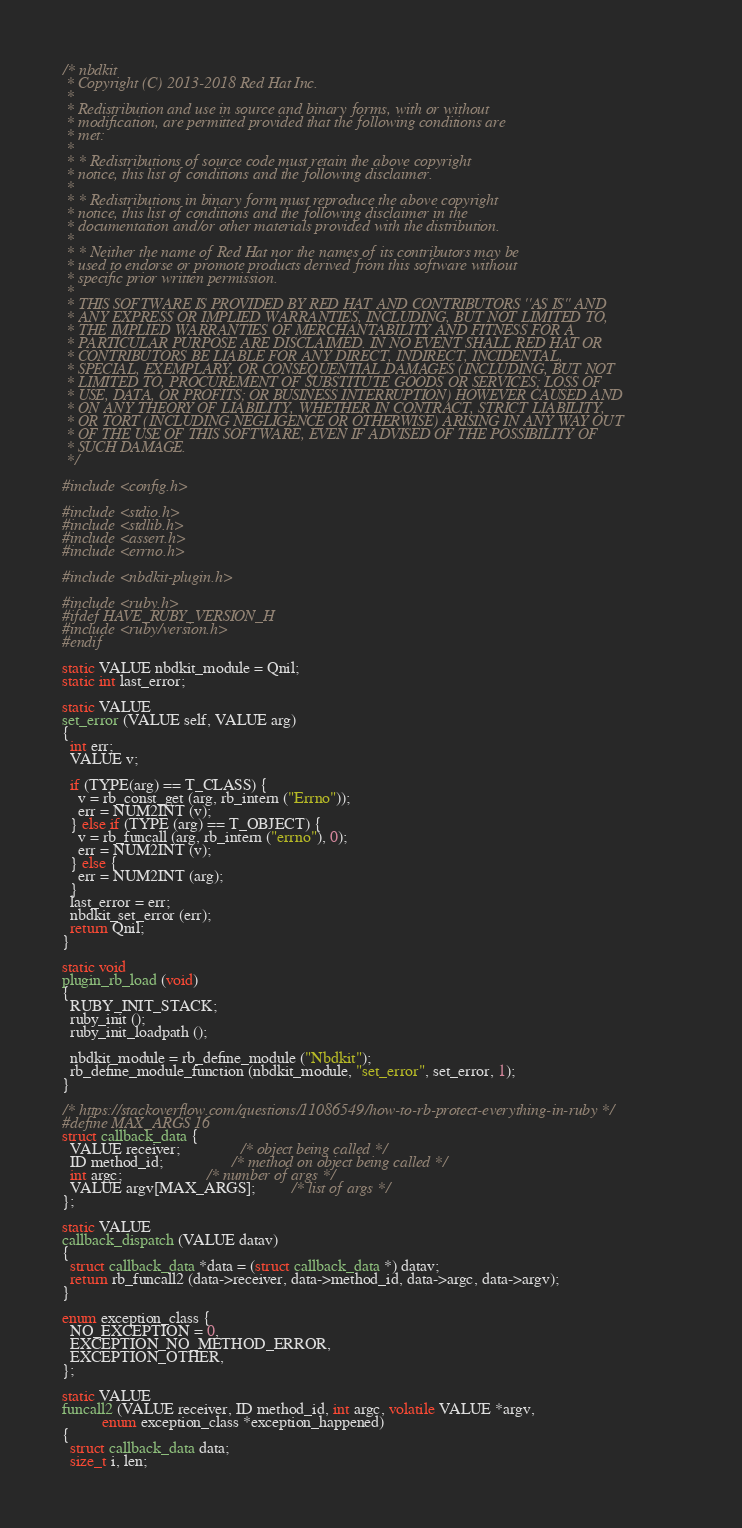Convert code to text. <code><loc_0><loc_0><loc_500><loc_500><_C_>/* nbdkit
 * Copyright (C) 2013-2018 Red Hat Inc.
 *
 * Redistribution and use in source and binary forms, with or without
 * modification, are permitted provided that the following conditions are
 * met:
 *
 * * Redistributions of source code must retain the above copyright
 * notice, this list of conditions and the following disclaimer.
 *
 * * Redistributions in binary form must reproduce the above copyright
 * notice, this list of conditions and the following disclaimer in the
 * documentation and/or other materials provided with the distribution.
 *
 * * Neither the name of Red Hat nor the names of its contributors may be
 * used to endorse or promote products derived from this software without
 * specific prior written permission.
 *
 * THIS SOFTWARE IS PROVIDED BY RED HAT AND CONTRIBUTORS ''AS IS'' AND
 * ANY EXPRESS OR IMPLIED WARRANTIES, INCLUDING, BUT NOT LIMITED TO,
 * THE IMPLIED WARRANTIES OF MERCHANTABILITY AND FITNESS FOR A
 * PARTICULAR PURPOSE ARE DISCLAIMED. IN NO EVENT SHALL RED HAT OR
 * CONTRIBUTORS BE LIABLE FOR ANY DIRECT, INDIRECT, INCIDENTAL,
 * SPECIAL, EXEMPLARY, OR CONSEQUENTIAL DAMAGES (INCLUDING, BUT NOT
 * LIMITED TO, PROCUREMENT OF SUBSTITUTE GOODS OR SERVICES; LOSS OF
 * USE, DATA, OR PROFITS; OR BUSINESS INTERRUPTION) HOWEVER CAUSED AND
 * ON ANY THEORY OF LIABILITY, WHETHER IN CONTRACT, STRICT LIABILITY,
 * OR TORT (INCLUDING NEGLIGENCE OR OTHERWISE) ARISING IN ANY WAY OUT
 * OF THE USE OF THIS SOFTWARE, EVEN IF ADVISED OF THE POSSIBILITY OF
 * SUCH DAMAGE.
 */

#include <config.h>

#include <stdio.h>
#include <stdlib.h>
#include <assert.h>
#include <errno.h>

#include <nbdkit-plugin.h>

#include <ruby.h>
#ifdef HAVE_RUBY_VERSION_H
#include <ruby/version.h>
#endif

static VALUE nbdkit_module = Qnil;
static int last_error;

static VALUE
set_error (VALUE self, VALUE arg)
{
  int err;
  VALUE v;

  if (TYPE(arg) == T_CLASS) {
    v = rb_const_get (arg, rb_intern ("Errno"));
    err = NUM2INT (v);
  } else if (TYPE (arg) == T_OBJECT) {
    v = rb_funcall (arg, rb_intern ("errno"), 0);
    err = NUM2INT (v);
  } else {
    err = NUM2INT (arg);
  }
  last_error = err;
  nbdkit_set_error (err);
  return Qnil;
}

static void
plugin_rb_load (void)
{
  RUBY_INIT_STACK;
  ruby_init ();
  ruby_init_loadpath ();

  nbdkit_module = rb_define_module ("Nbdkit");
  rb_define_module_function (nbdkit_module, "set_error", set_error, 1);
}

/* https://stackoverflow.com/questions/11086549/how-to-rb-protect-everything-in-ruby */
#define MAX_ARGS 16
struct callback_data {
  VALUE receiver;               /* object being called */
  ID method_id;                 /* method on object being called */
  int argc;                     /* number of args */
  VALUE argv[MAX_ARGS];         /* list of args */
};

static VALUE
callback_dispatch (VALUE datav)
{
  struct callback_data *data = (struct callback_data *) datav;
  return rb_funcall2 (data->receiver, data->method_id, data->argc, data->argv);
}

enum exception_class {
  NO_EXCEPTION = 0,
  EXCEPTION_NO_METHOD_ERROR,
  EXCEPTION_OTHER,
};

static VALUE
funcall2 (VALUE receiver, ID method_id, int argc, volatile VALUE *argv,
          enum exception_class *exception_happened)
{
  struct callback_data data;
  size_t i, len;</code> 